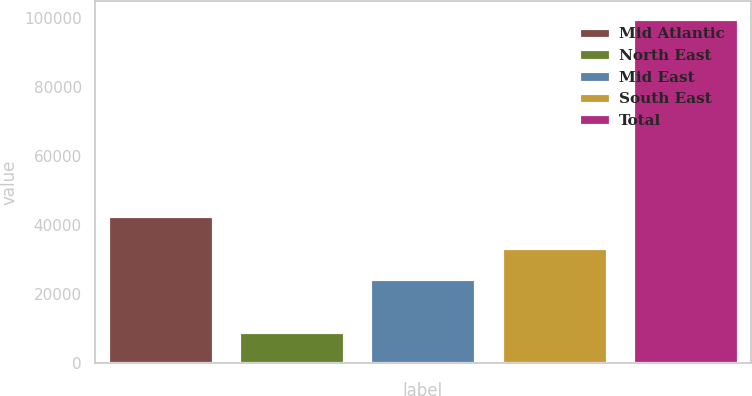Convert chart to OTSL. <chart><loc_0><loc_0><loc_500><loc_500><bar_chart><fcel>Mid Atlantic<fcel>North East<fcel>Mid East<fcel>South East<fcel>Total<nl><fcel>42500<fcel>8950<fcel>24350<fcel>33425<fcel>99700<nl></chart> 